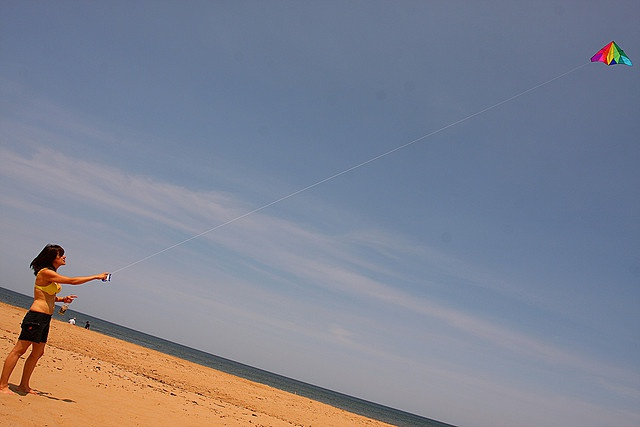Describe the objects in this image and their specific colors. I can see people in gray, black, orange, darkgray, and maroon tones, kite in gray, red, teal, darkgreen, and purple tones, people in gray, black, lightgray, and salmon tones, and people in gray, black, and maroon tones in this image. 